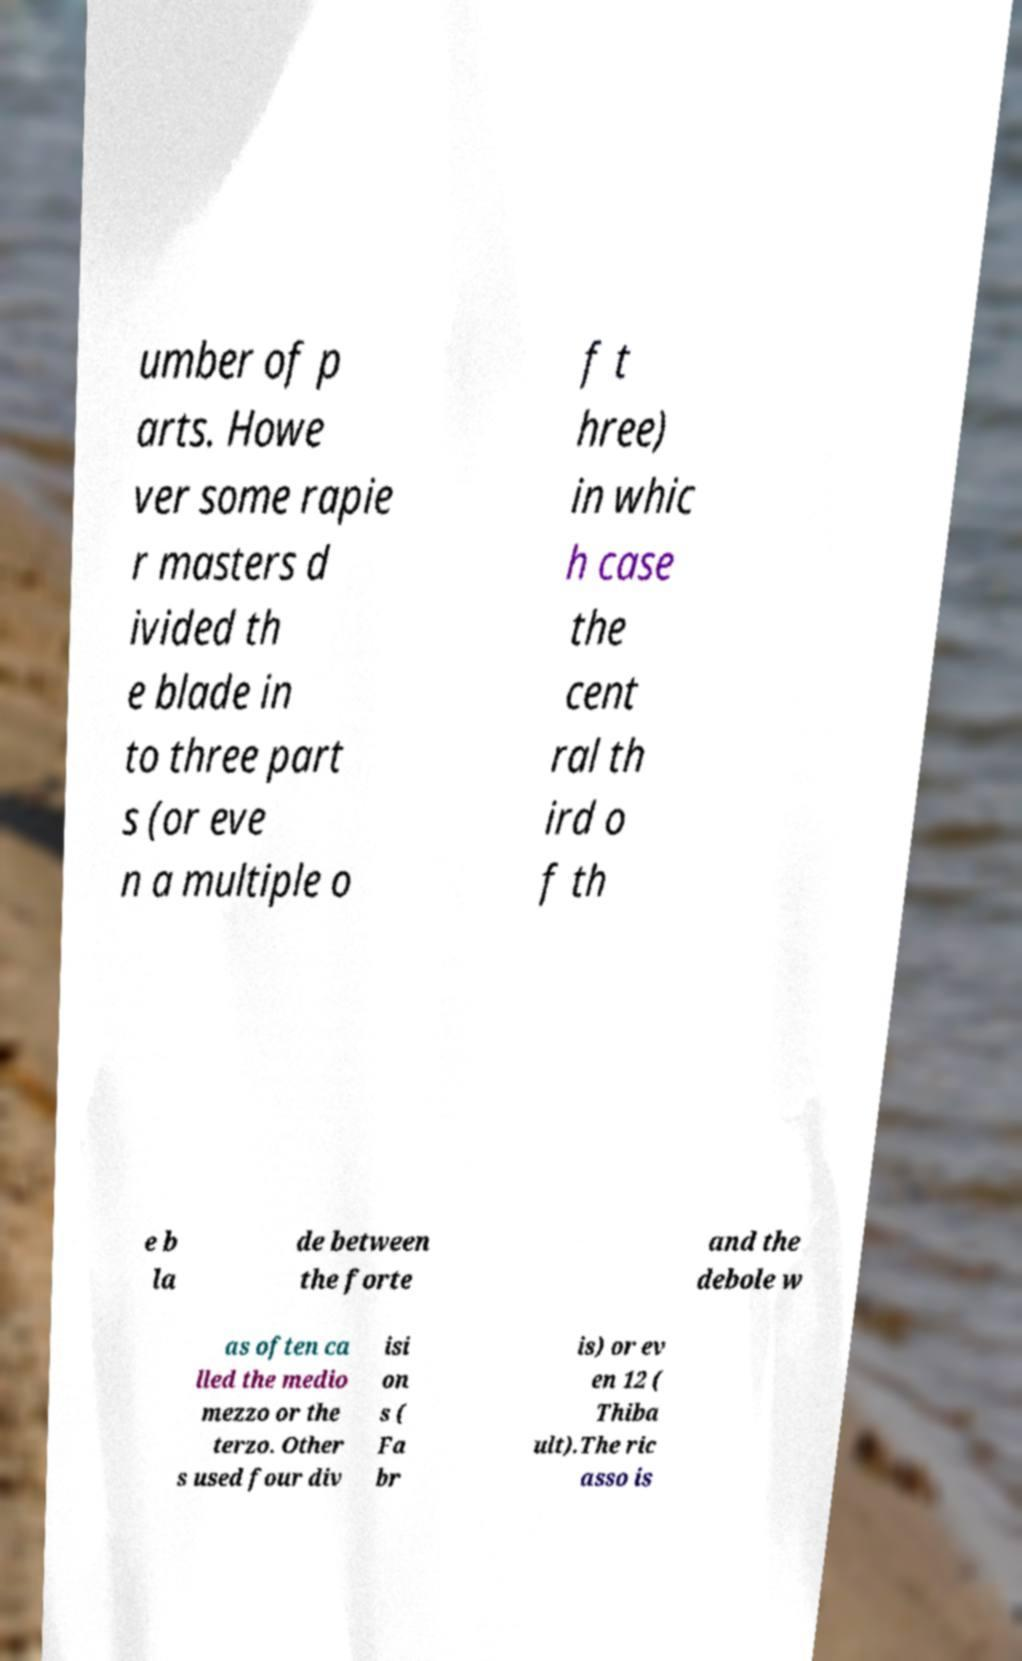Could you extract and type out the text from this image? umber of p arts. Howe ver some rapie r masters d ivided th e blade in to three part s (or eve n a multiple o f t hree) in whic h case the cent ral th ird o f th e b la de between the forte and the debole w as often ca lled the medio mezzo or the terzo. Other s used four div isi on s ( Fa br is) or ev en 12 ( Thiba ult).The ric asso is 